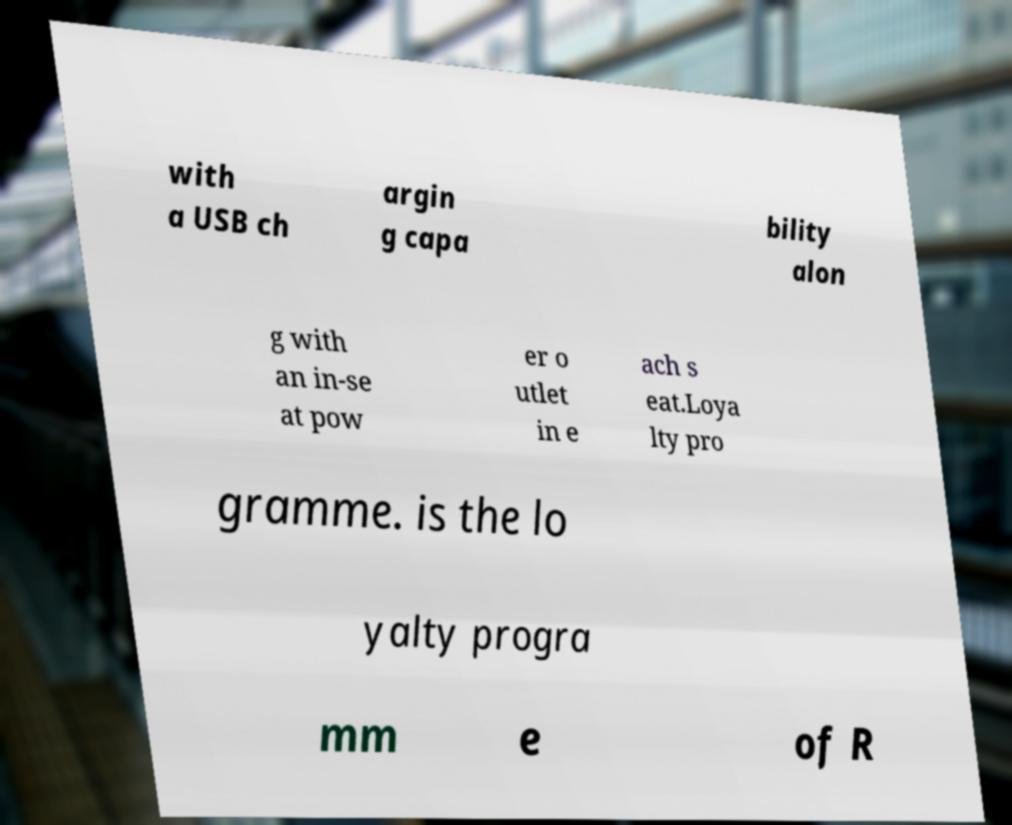What messages or text are displayed in this image? I need them in a readable, typed format. with a USB ch argin g capa bility alon g with an in-se at pow er o utlet in e ach s eat.Loya lty pro gramme. is the lo yalty progra mm e of R 